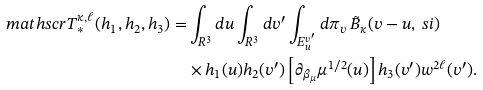Convert formula to latex. <formula><loc_0><loc_0><loc_500><loc_500>\ m a t h s c r { T } _ { \ast } ^ { \kappa , \ell } ( h _ { 1 } , h _ { 2 } , h _ { 3 } ) = & \int _ { { R } ^ { 3 } } d u \int _ { { R } ^ { 3 } } d v ^ { \prime } \int _ { E _ { u } ^ { v ^ { \prime } } } d \pi _ { v } \, \tilde { B } _ { \kappa } ( v - u , \ s i ) \\ & \times h _ { 1 } ( u ) h _ { 2 } ( v ^ { \prime } ) \left [ \partial _ { \beta _ { \mu } } \mu ^ { 1 / 2 } ( u ) \right ] h _ { 3 } ( v ^ { \prime } ) w ^ { 2 \ell } ( v ^ { \prime } ) .</formula> 